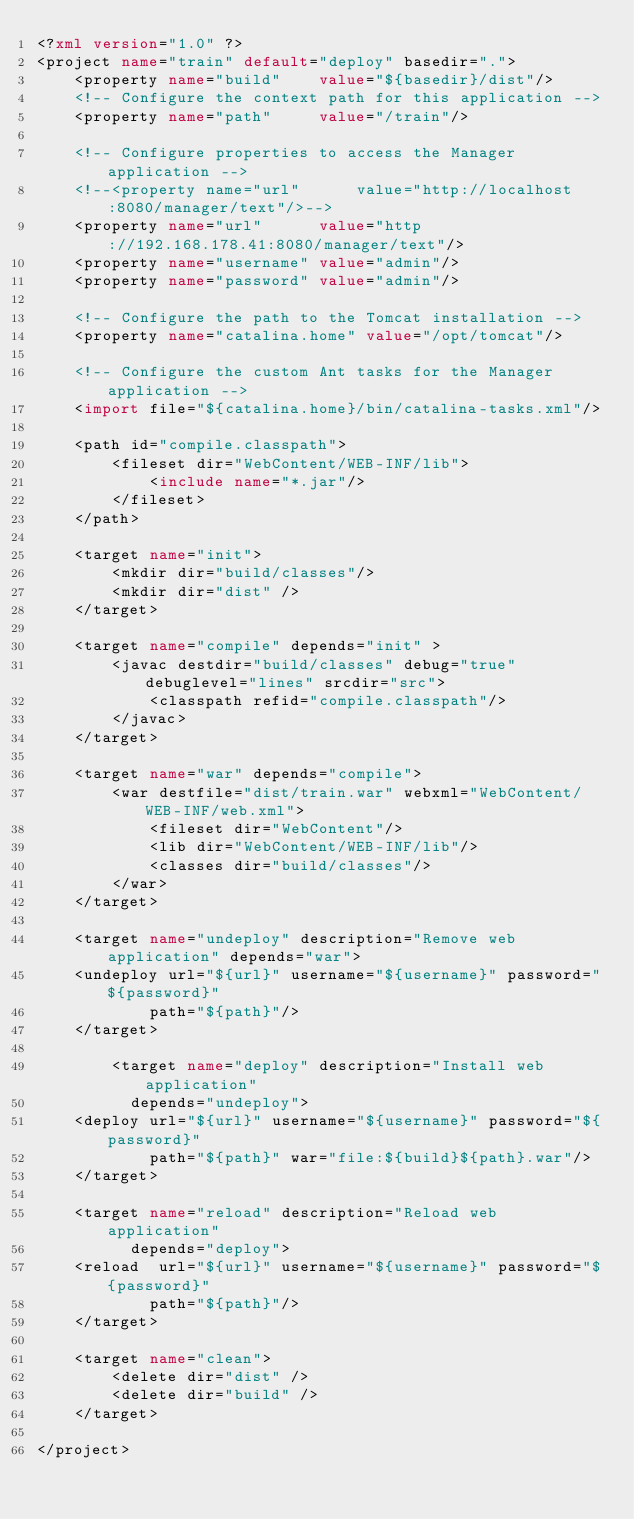Convert code to text. <code><loc_0><loc_0><loc_500><loc_500><_XML_><?xml version="1.0" ?> 
<project name="train" default="deploy" basedir=".">
    <property name="build"    value="${basedir}/dist"/>
    <!-- Configure the context path for this application -->
    <property name="path"     value="/train"/>

    <!-- Configure properties to access the Manager application -->
    <!--<property name="url"      value="http://localhost:8080/manager/text"/>-->
    <property name="url"      value="http://192.168.178.41:8080/manager/text"/>
    <property name="username" value="admin"/>
    <property name="password" value="admin"/>

    <!-- Configure the path to the Tomcat installation -->
    <property name="catalina.home" value="/opt/tomcat"/>

    <!-- Configure the custom Ant tasks for the Manager application -->
    <import file="${catalina.home}/bin/catalina-tasks.xml"/>

    <path id="compile.classpath">
        <fileset dir="WebContent/WEB-INF/lib">
            <include name="*.jar"/>
        </fileset>
    </path>
    
    <target name="init">
        <mkdir dir="build/classes"/>
        <mkdir dir="dist" />
    </target>
    
    <target name="compile" depends="init" >
        <javac destdir="build/classes" debug="true" debuglevel="lines" srcdir="src">
            <classpath refid="compile.classpath"/>
        </javac>
    </target>
    
    <target name="war" depends="compile">
        <war destfile="dist/train.war" webxml="WebContent/WEB-INF/web.xml">
            <fileset dir="WebContent"/>
            <lib dir="WebContent/WEB-INF/lib"/>
            <classes dir="build/classes"/>
        </war>
    </target>

    <target name="undeploy" description="Remove web application" depends="war">
    <undeploy url="${url}" username="${username}" password="${password}"
            path="${path}"/>
    </target>

        <target name="deploy" description="Install web application"
          depends="undeploy">
    <deploy url="${url}" username="${username}" password="${password}"
            path="${path}" war="file:${build}${path}.war"/>
    </target>

    <target name="reload" description="Reload web application"
          depends="deploy">
    <reload  url="${url}" username="${username}" password="${password}"
            path="${path}"/>
    </target>
    
    <target name="clean">
        <delete dir="dist" />
        <delete dir="build" />
    </target>
    
</project>
</code> 